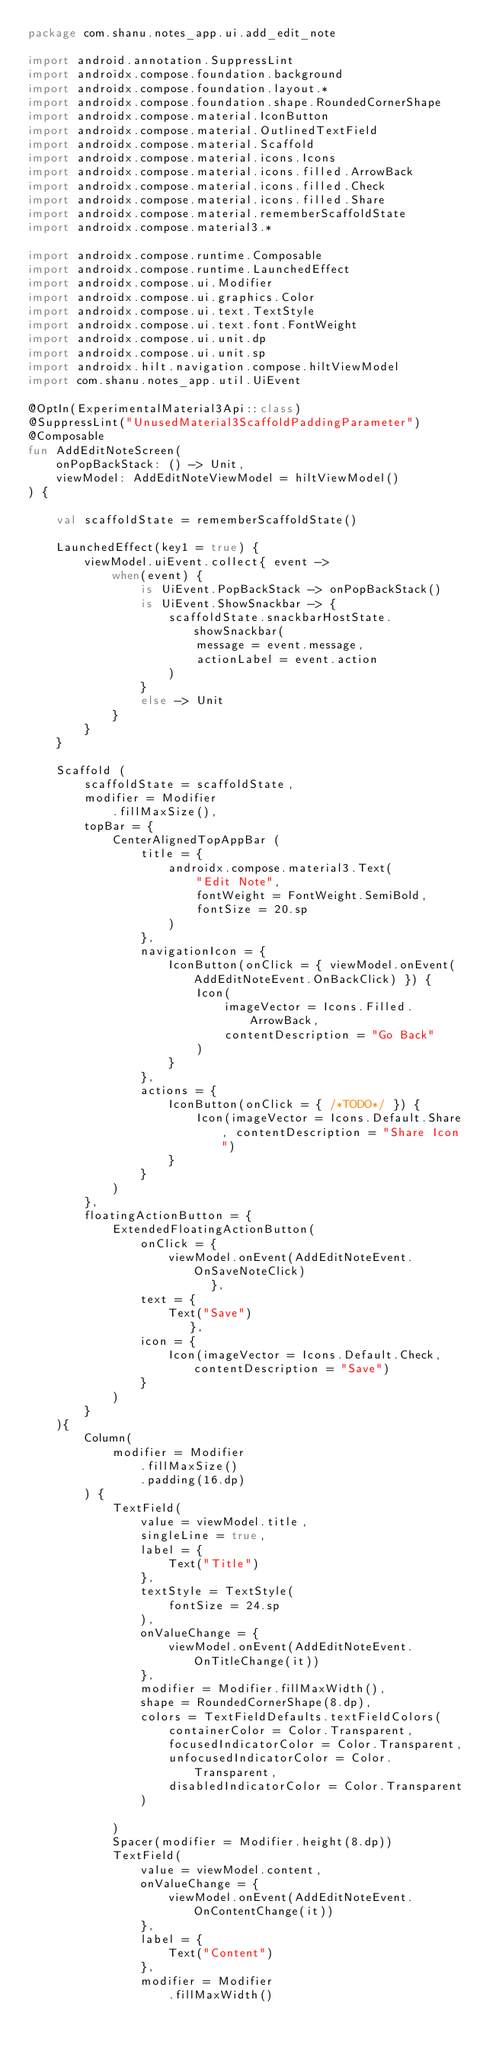<code> <loc_0><loc_0><loc_500><loc_500><_Kotlin_>package com.shanu.notes_app.ui.add_edit_note

import android.annotation.SuppressLint
import androidx.compose.foundation.background
import androidx.compose.foundation.layout.*
import androidx.compose.foundation.shape.RoundedCornerShape
import androidx.compose.material.IconButton
import androidx.compose.material.OutlinedTextField
import androidx.compose.material.Scaffold
import androidx.compose.material.icons.Icons
import androidx.compose.material.icons.filled.ArrowBack
import androidx.compose.material.icons.filled.Check
import androidx.compose.material.icons.filled.Share
import androidx.compose.material.rememberScaffoldState
import androidx.compose.material3.*

import androidx.compose.runtime.Composable
import androidx.compose.runtime.LaunchedEffect
import androidx.compose.ui.Modifier
import androidx.compose.ui.graphics.Color
import androidx.compose.ui.text.TextStyle
import androidx.compose.ui.text.font.FontWeight
import androidx.compose.ui.unit.dp
import androidx.compose.ui.unit.sp
import androidx.hilt.navigation.compose.hiltViewModel
import com.shanu.notes_app.util.UiEvent

@OptIn(ExperimentalMaterial3Api::class)
@SuppressLint("UnusedMaterial3ScaffoldPaddingParameter")
@Composable
fun AddEditNoteScreen(
    onPopBackStack: () -> Unit,
    viewModel: AddEditNoteViewModel = hiltViewModel()
) {

    val scaffoldState = rememberScaffoldState()

    LaunchedEffect(key1 = true) {
        viewModel.uiEvent.collect{ event ->
            when(event) {
                is UiEvent.PopBackStack -> onPopBackStack()
                is UiEvent.ShowSnackbar -> {
                    scaffoldState.snackbarHostState.showSnackbar(
                        message = event.message,
                        actionLabel = event.action
                    )
                }
                else -> Unit
            }
        }
    }

    Scaffold (
        scaffoldState = scaffoldState,
        modifier = Modifier
            .fillMaxSize(),
        topBar = {
            CenterAlignedTopAppBar (
                title = {
                    androidx.compose.material3.Text(
                        "Edit Note",
                        fontWeight = FontWeight.SemiBold,
                        fontSize = 20.sp
                    )
                },
                navigationIcon = {
                    IconButton(onClick = { viewModel.onEvent(AddEditNoteEvent.OnBackClick) }) {
                        Icon(
                            imageVector = Icons.Filled.ArrowBack,
                            contentDescription = "Go Back"
                        )
                    }
                },
                actions = {
                    IconButton(onClick = { /*TODO*/ }) {
                        Icon(imageVector = Icons.Default.Share, contentDescription = "Share Icon")
                    }
                }
            )
        },
        floatingActionButton = {
            ExtendedFloatingActionButton(
                onClick = {
                    viewModel.onEvent(AddEditNoteEvent.OnSaveNoteClick)
                          },
                text = {
                    Text("Save")
                       },
                icon = {
                    Icon(imageVector = Icons.Default.Check, contentDescription = "Save")
                }
            )
        }
    ){
        Column(
            modifier = Modifier
                .fillMaxSize()
                .padding(16.dp)
        ) {
            TextField(
                value = viewModel.title,
                singleLine = true,
                label = {
                    Text("Title")
                },
                textStyle = TextStyle(
                    fontSize = 24.sp
                ),
                onValueChange = {
                    viewModel.onEvent(AddEditNoteEvent.OnTitleChange(it))
                },
                modifier = Modifier.fillMaxWidth(),
                shape = RoundedCornerShape(8.dp),
                colors = TextFieldDefaults.textFieldColors(
                    containerColor = Color.Transparent,
                    focusedIndicatorColor = Color.Transparent,
                    unfocusedIndicatorColor = Color.Transparent,
                    disabledIndicatorColor = Color.Transparent
                )

            )
            Spacer(modifier = Modifier.height(8.dp))
            TextField(
                value = viewModel.content,
                onValueChange = {
                    viewModel.onEvent(AddEditNoteEvent.OnContentChange(it))
                },
                label = {
                    Text("Content")
                },
                modifier = Modifier
                    .fillMaxWidth()</code> 